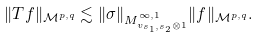<formula> <loc_0><loc_0><loc_500><loc_500>\| T f \| _ { \mathcal { M } ^ { p , q } } \lesssim \| \sigma \| _ { M _ { v _ { s _ { 1 } , s _ { 2 } } \otimes 1 } ^ { \infty , 1 } } \| f \| _ { \mathcal { M } ^ { p , q } } .</formula> 